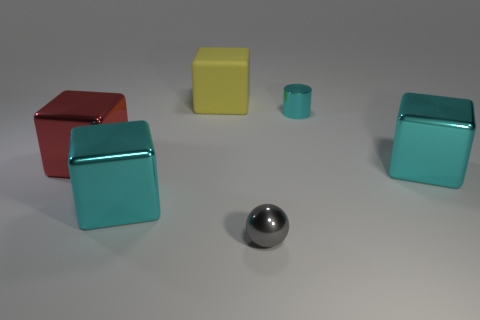Describe the layout of the objects in this image. There are five objects arranged in an arc formation across the image: starting from the left, there is a red cube, followed by a smaller yellow cube, a small turquoise cylinder, a slightly larger turquoise cube, and a small gray sphere is in the forefront of the image. 